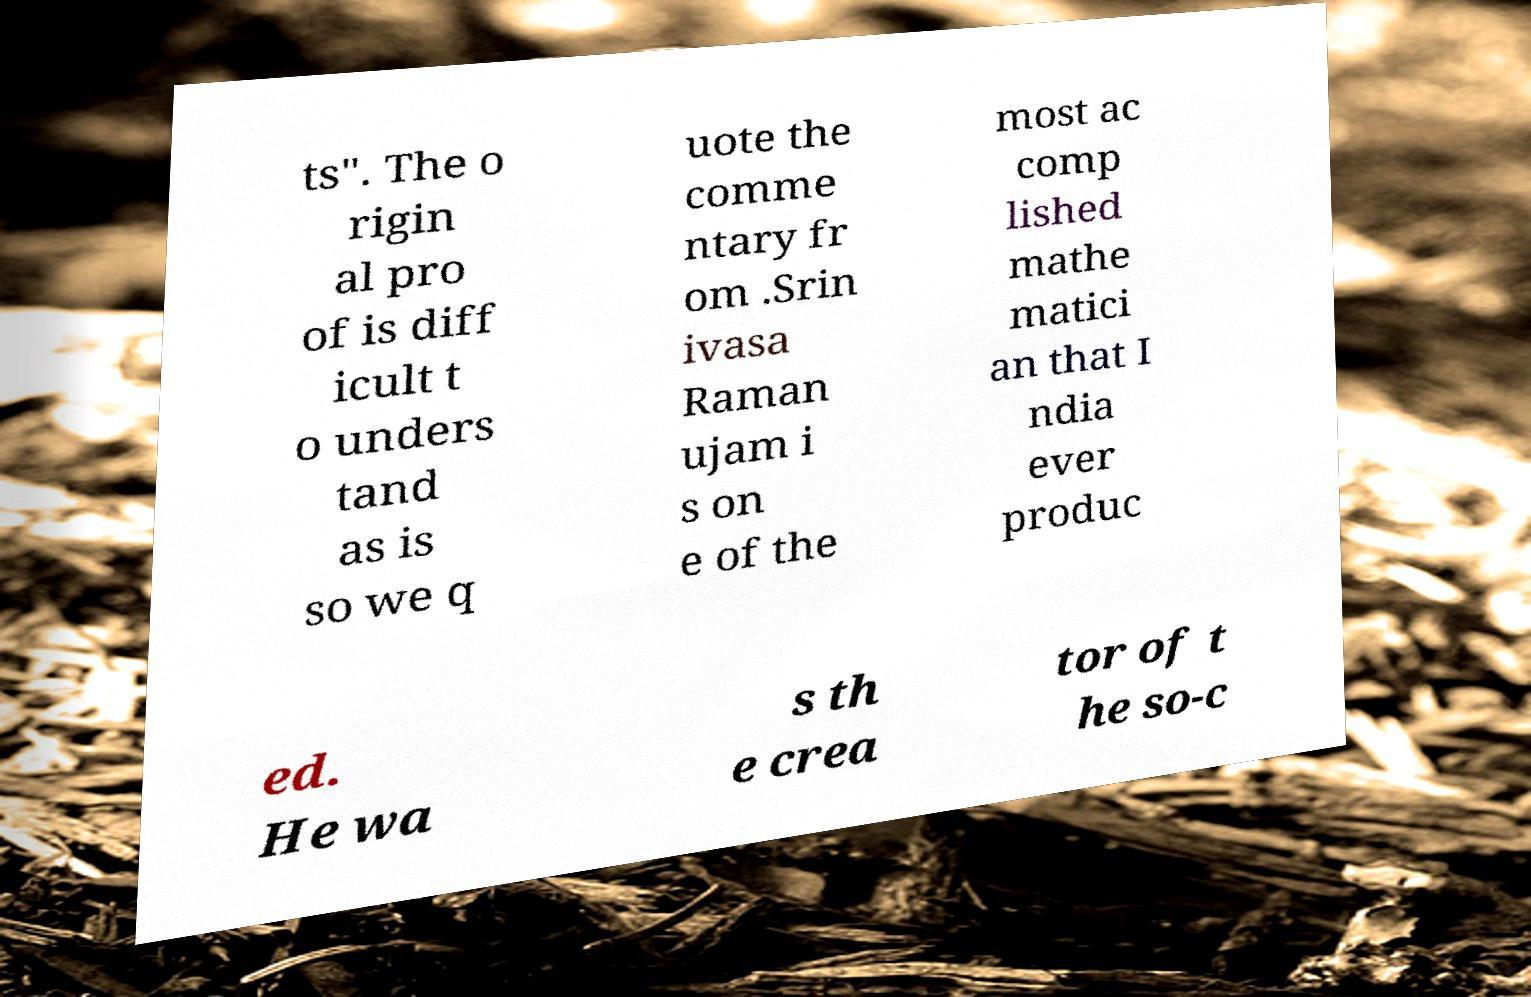I need the written content from this picture converted into text. Can you do that? ts". The o rigin al pro of is diff icult t o unders tand as is so we q uote the comme ntary fr om .Srin ivasa Raman ujam i s on e of the most ac comp lished mathe matici an that I ndia ever produc ed. He wa s th e crea tor of t he so-c 